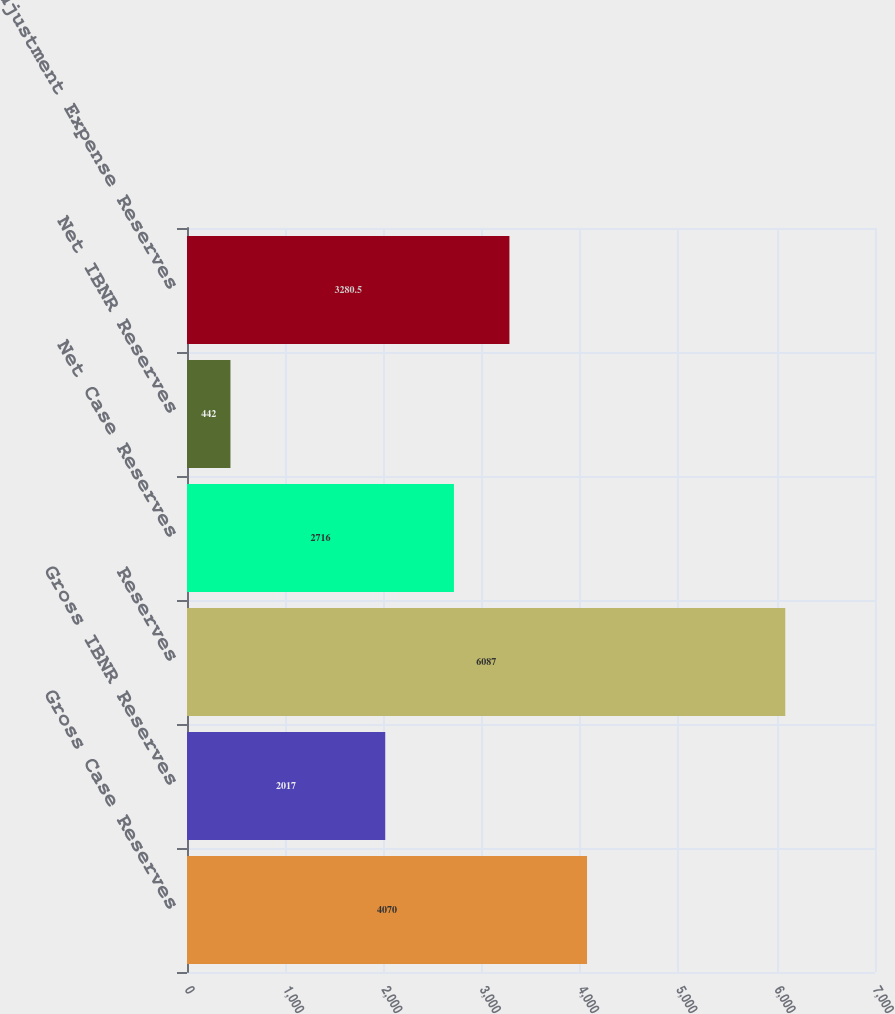<chart> <loc_0><loc_0><loc_500><loc_500><bar_chart><fcel>Gross Case Reserves<fcel>Gross IBNR Reserves<fcel>Reserves<fcel>Net Case Reserves<fcel>Net IBNR Reserves<fcel>Adjustment Expense Reserves<nl><fcel>4070<fcel>2017<fcel>6087<fcel>2716<fcel>442<fcel>3280.5<nl></chart> 